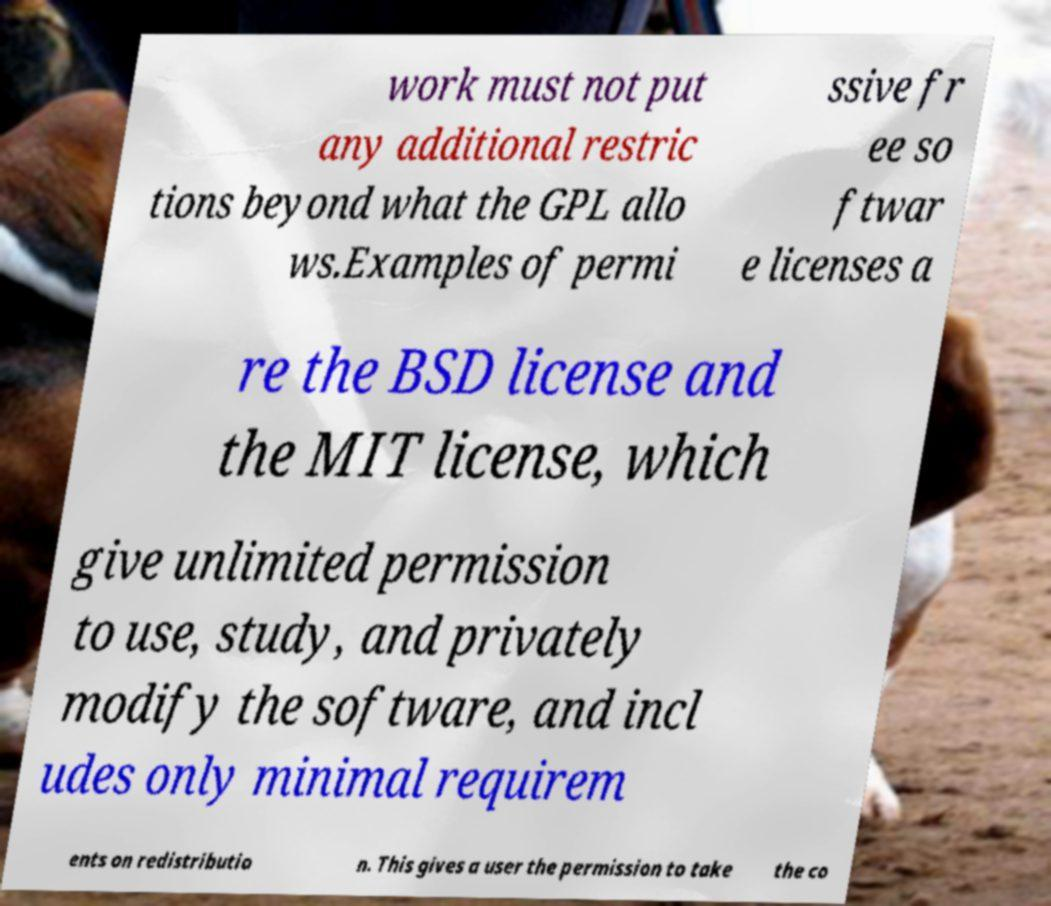Can you read and provide the text displayed in the image?This photo seems to have some interesting text. Can you extract and type it out for me? work must not put any additional restric tions beyond what the GPL allo ws.Examples of permi ssive fr ee so ftwar e licenses a re the BSD license and the MIT license, which give unlimited permission to use, study, and privately modify the software, and incl udes only minimal requirem ents on redistributio n. This gives a user the permission to take the co 